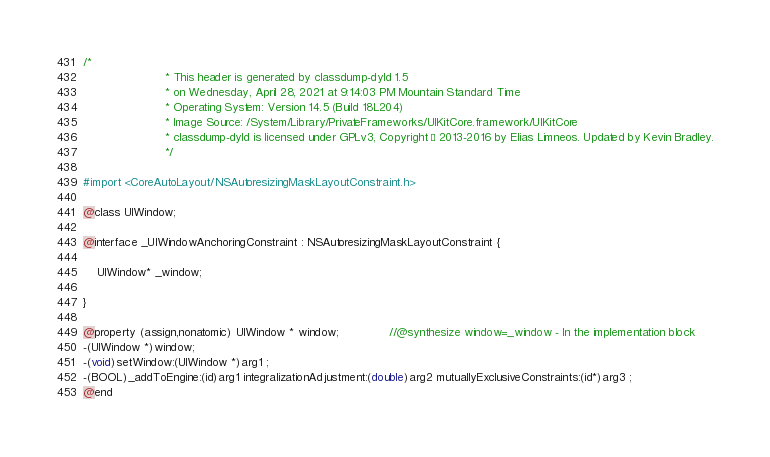Convert code to text. <code><loc_0><loc_0><loc_500><loc_500><_C_>/*
                       * This header is generated by classdump-dyld 1.5
                       * on Wednesday, April 28, 2021 at 9:14:03 PM Mountain Standard Time
                       * Operating System: Version 14.5 (Build 18L204)
                       * Image Source: /System/Library/PrivateFrameworks/UIKitCore.framework/UIKitCore
                       * classdump-dyld is licensed under GPLv3, Copyright © 2013-2016 by Elias Limneos. Updated by Kevin Bradley.
                       */

#import <CoreAutoLayout/NSAutoresizingMaskLayoutConstraint.h>

@class UIWindow;

@interface _UIWindowAnchoringConstraint : NSAutoresizingMaskLayoutConstraint {

	UIWindow* _window;

}

@property (assign,nonatomic) UIWindow * window;              //@synthesize window=_window - In the implementation block
-(UIWindow *)window;
-(void)setWindow:(UIWindow *)arg1 ;
-(BOOL)_addToEngine:(id)arg1 integralizationAdjustment:(double)arg2 mutuallyExclusiveConstraints:(id*)arg3 ;
@end

</code> 